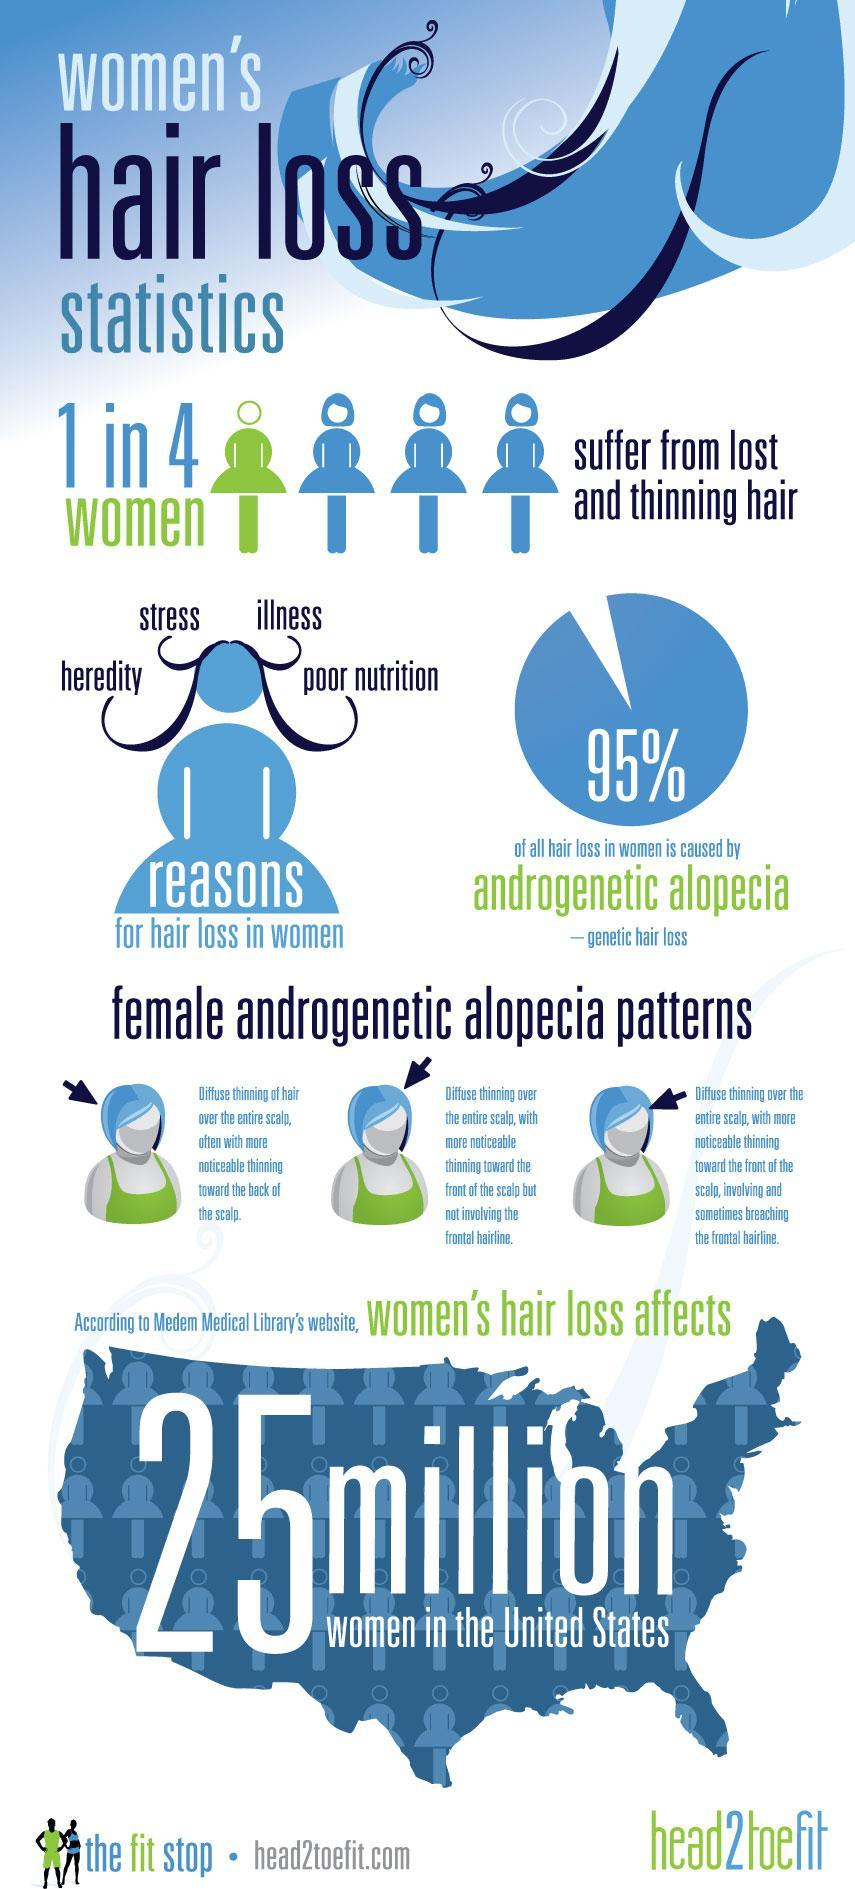What percentage of women lose hair due to reasons other than androgenetic alopecia?
Answer the question with a short phrase. 5% 